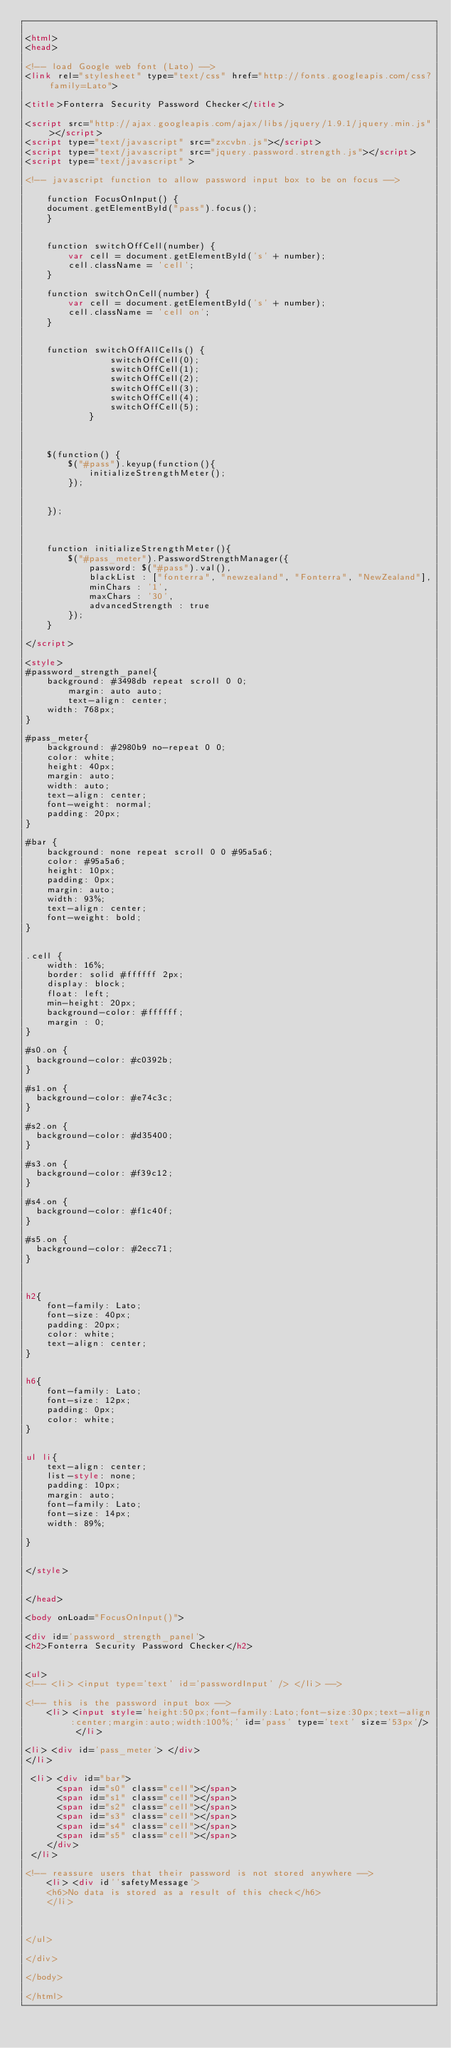Convert code to text. <code><loc_0><loc_0><loc_500><loc_500><_HTML_>
<html>
<head>

<!-- load Google web font (Lato) -->
<link rel="stylesheet" type="text/css" href="http://fonts.googleapis.com/css?family=Lato">

<title>Fonterra Security Password Checker</title>

<script src="http://ajax.googleapis.com/ajax/libs/jquery/1.9.1/jquery.min.js"></script>
<script type="text/javascript" src="zxcvbn.js"></script>
<script type="text/javascript" src="jquery.password.strength.js"></script>
<script type="text/javascript" >

<!-- javascript function to allow password input box to be on focus -->

	function FocusOnInput() {
	document.getElementById("pass").focus();
	}


	function switchOffCell(number) {
		var cell = document.getElementById('s' + number);
		cell.className = 'cell';
	}

	function switchOnCell(number) {
		var cell = document.getElementById('s' + number);
		cell.className = 'cell on';
	}


	function switchOffAllCells() {
				switchOffCell(0);
				switchOffCell(1);
				switchOffCell(2);
				switchOffCell(3);
				switchOffCell(4);
				switchOffCell(5);
			}

	

	$(function() {
		$("#pass").keyup(function(){
			initializeStrengthMeter();
		});

		
	});
	
	

	function initializeStrengthMeter(){
		$("#pass_meter").PasswordStrengthManager({
			password: $("#pass").val(),
			blackList : ["fonterra", "newzealand", "Fonterra", "NewZealand"], 
			minChars : '1',
			maxChars : '30',
			advancedStrength : true
		});
	}

</script>

<style>
#password_strength_panel{
	background: #3498db repeat scroll 0 0;
    	margin: auto auto;
    	text-align: center;
   	width: 768px;
}

#pass_meter{
	background: #2980b9 no-repeat 0 0;
	color: white;
	height: 40px;
	margin: auto;
	width: auto;
	text-align: center;
	font-weight: normal;
	padding: 20px;
}

#bar {
	background: none repeat scroll 0 0 #95a5a6;
	color: #95a5a6;
	height: 10px;
	padding: 0px;
	margin: auto;
	width: 93%;
	text-align: center;
	font-weight: bold;
}


.cell {
	width: 16%;
	border: solid #ffffff 2px;
	display: block;
	float: left;
	min-height: 20px;
	background-color: #ffffff;
	margin : 0;
}

#s0.on {
  background-color: #c0392b;
}

#s1.on {
  background-color: #e74c3c;
}

#s2.on {
  background-color: #d35400;
}

#s3.on {
  background-color: #f39c12;
}

#s4.on {
  background-color: #f1c40f;
}

#s5.on {
  background-color: #2ecc71;
}



h2{
	font-family: Lato;
	font-size: 40px;
    padding: 20px;
	color: white;
	text-align: center;
}


h6{
	font-family: Lato;
	font-size: 12px;
    padding: 0px;
	color: white;
}


ul li{
	text-align: center;
	list-style: none;
	padding: 10px;
	margin: auto;
	font-family: Lato;
	font-size: 14px;
	width: 89%;
	
}


</style>


</head>

<body onLoad="FocusOnInput()">

<div id='password_strength_panel'>
<h2>Fonterra Security Password Checker</h2>


<ul>
<!-- <li> <input type='text' id='passwordInput' /> </li> -->

<!-- this is the password input box -->
	<li> <input style='height:50px;font-family:Lato;font-size:30px;text-align:center;margin:auto;width:100%;' id='pass' type='text' size='53px'/> </li>
	
<li> <div id='pass_meter'> </div> 
</li>

 <li> <div id="bar">
      <span id="s0" class="cell"></span>
      <span id="s1" class="cell"></span>
      <span id="s2" class="cell"></span>
      <span id="s3" class="cell"></span>
      <span id="s4" class="cell"></span>
      <span id="s5" class="cell"></span>
    </div> 
 </li>
	
<!-- reassure users that their password is not stored anywhere --> 
	<li> <div id''safetyMessage'> 
	<h6>No data is stored as a result of this check</h6>
	</li>
	


</ul>

</div>

</body>

</html>




</code> 